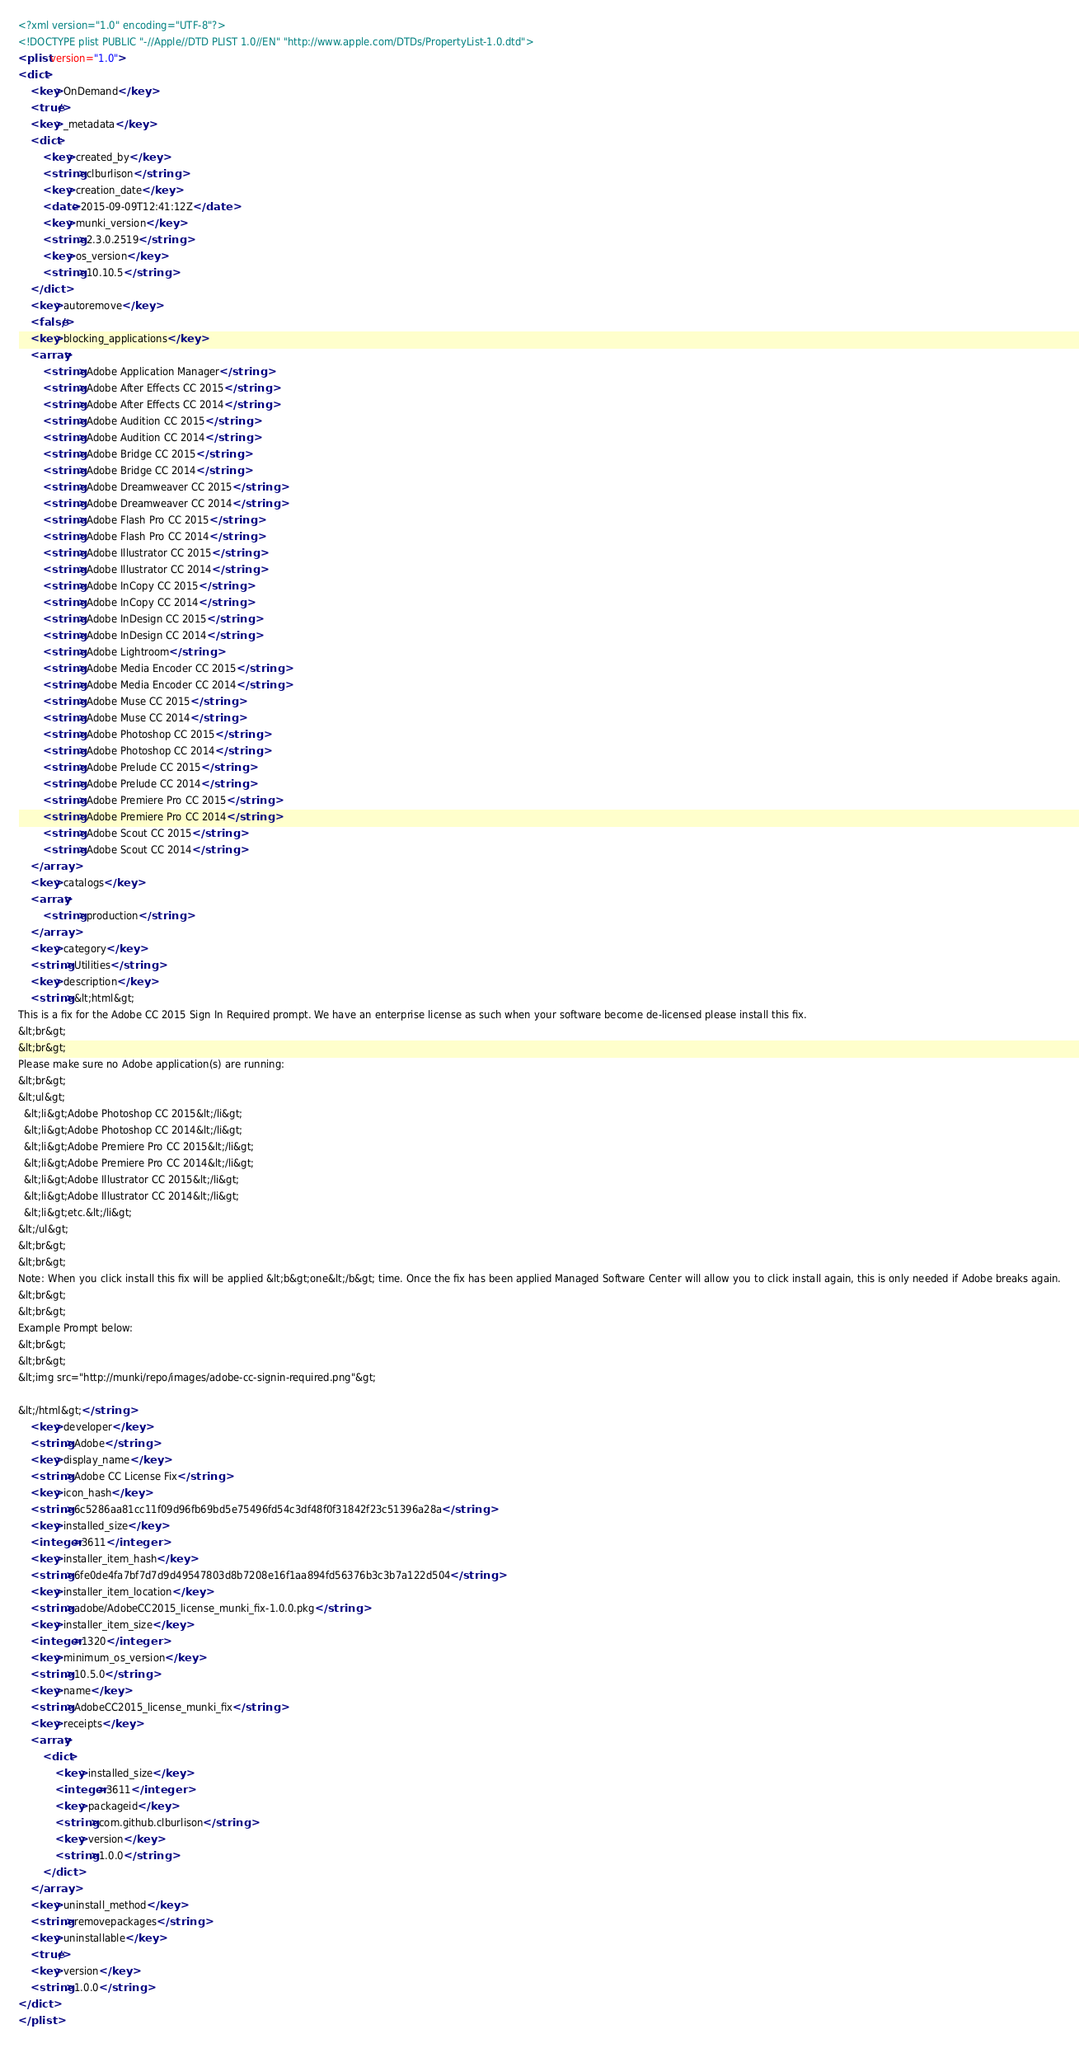Convert code to text. <code><loc_0><loc_0><loc_500><loc_500><_XML_><?xml version="1.0" encoding="UTF-8"?>
<!DOCTYPE plist PUBLIC "-//Apple//DTD PLIST 1.0//EN" "http://www.apple.com/DTDs/PropertyList-1.0.dtd">
<plist version="1.0">
<dict>
	<key>OnDemand</key>
	<true/>
	<key>_metadata</key>
	<dict>
		<key>created_by</key>
		<string>clburlison</string>
		<key>creation_date</key>
		<date>2015-09-09T12:41:12Z</date>
		<key>munki_version</key>
		<string>2.3.0.2519</string>
		<key>os_version</key>
		<string>10.10.5</string>
	</dict>
	<key>autoremove</key>
	<false/>
	<key>blocking_applications</key>
	<array>
		<string>Adobe Application Manager</string>
		<string>Adobe After Effects CC 2015</string>
		<string>Adobe After Effects CC 2014</string>
		<string>Adobe Audition CC 2015</string>
		<string>Adobe Audition CC 2014</string>
		<string>Adobe Bridge CC 2015</string>
		<string>Adobe Bridge CC 2014</string>
		<string>Adobe Dreamweaver CC 2015</string>
		<string>Adobe Dreamweaver CC 2014</string>
		<string>Adobe Flash Pro CC 2015</string>
		<string>Adobe Flash Pro CC 2014</string>
		<string>Adobe Illustrator CC 2015</string>
		<string>Adobe Illustrator CC 2014</string>
		<string>Adobe InCopy CC 2015</string>
		<string>Adobe InCopy CC 2014</string>
		<string>Adobe InDesign CC 2015</string>
		<string>Adobe InDesign CC 2014</string>
		<string>Adobe Lightroom</string>
		<string>Adobe Media Encoder CC 2015</string>
		<string>Adobe Media Encoder CC 2014</string>
		<string>Adobe Muse CC 2015</string>
		<string>Adobe Muse CC 2014</string>
		<string>Adobe Photoshop CC 2015</string>
		<string>Adobe Photoshop CC 2014</string>
		<string>Adobe Prelude CC 2015</string>
		<string>Adobe Prelude CC 2014</string>
		<string>Adobe Premiere Pro CC 2015</string>
		<string>Adobe Premiere Pro CC 2014</string>
		<string>Adobe Scout CC 2015</string>
		<string>Adobe Scout CC 2014</string>
	</array>
	<key>catalogs</key>
	<array>
		<string>production</string>
	</array>
	<key>category</key>
	<string>Utilities</string>
	<key>description</key>
	<string>&lt;html&gt;
This is a fix for the Adobe CC 2015 Sign In Required prompt. We have an enterprise license as such when your software become de-licensed please install this fix. 
&lt;br&gt;
&lt;br&gt;
Please make sure no Adobe application(s) are running:
&lt;br&gt;
&lt;ul&gt;
  &lt;li&gt;Adobe Photoshop CC 2015&lt;/li&gt;
  &lt;li&gt;Adobe Photoshop CC 2014&lt;/li&gt;
  &lt;li&gt;Adobe Premiere Pro CC 2015&lt;/li&gt;
  &lt;li&gt;Adobe Premiere Pro CC 2014&lt;/li&gt;
  &lt;li&gt;Adobe Illustrator CC 2015&lt;/li&gt;
  &lt;li&gt;Adobe Illustrator CC 2014&lt;/li&gt;
  &lt;li&gt;etc.&lt;/li&gt;
&lt;/ul&gt;
&lt;br&gt;
&lt;br&gt;
Note: When you click install this fix will be applied &lt;b&gt;one&lt;/b&gt; time. Once the fix has been applied Managed Software Center will allow you to click install again, this is only needed if Adobe breaks again.
&lt;br&gt;
&lt;br&gt;
Example Prompt below:
&lt;br&gt;
&lt;br&gt;
&lt;img src="http://munki/repo/images/adobe-cc-signin-required.png"&gt;
    
&lt;/html&gt;</string>
	<key>developer</key>
	<string>Adobe</string>
	<key>display_name</key>
	<string>Adobe CC License Fix</string>
	<key>icon_hash</key>
	<string>6c5286aa81cc11f09d96fb69bd5e75496fd54c3df48f0f31842f23c51396a28a</string>
	<key>installed_size</key>
	<integer>3611</integer>
	<key>installer_item_hash</key>
	<string>6fe0de4fa7bf7d7d9d49547803d8b7208e16f1aa894fd56376b3c3b7a122d504</string>
	<key>installer_item_location</key>
	<string>adobe/AdobeCC2015_license_munki_fix-1.0.0.pkg</string>
	<key>installer_item_size</key>
	<integer>1320</integer>
	<key>minimum_os_version</key>
	<string>10.5.0</string>
	<key>name</key>
	<string>AdobeCC2015_license_munki_fix</string>
	<key>receipts</key>
	<array>
		<dict>
			<key>installed_size</key>
			<integer>3611</integer>
			<key>packageid</key>
			<string>com.github.clburlison</string>
			<key>version</key>
			<string>1.0.0</string>
		</dict>
	</array>
	<key>uninstall_method</key>
	<string>removepackages</string>
	<key>uninstallable</key>
	<true/>
	<key>version</key>
	<string>1.0.0</string>
</dict>
</plist>
</code> 